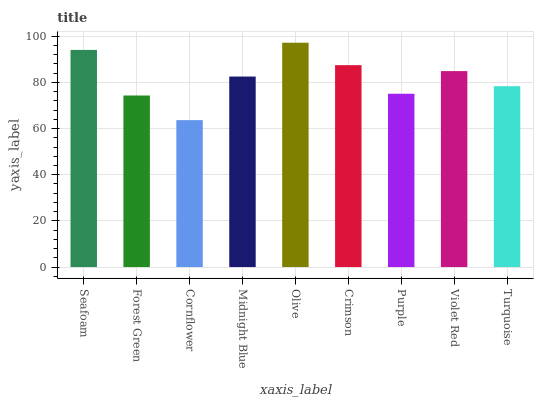Is Cornflower the minimum?
Answer yes or no. Yes. Is Olive the maximum?
Answer yes or no. Yes. Is Forest Green the minimum?
Answer yes or no. No. Is Forest Green the maximum?
Answer yes or no. No. Is Seafoam greater than Forest Green?
Answer yes or no. Yes. Is Forest Green less than Seafoam?
Answer yes or no. Yes. Is Forest Green greater than Seafoam?
Answer yes or no. No. Is Seafoam less than Forest Green?
Answer yes or no. No. Is Midnight Blue the high median?
Answer yes or no. Yes. Is Midnight Blue the low median?
Answer yes or no. Yes. Is Purple the high median?
Answer yes or no. No. Is Olive the low median?
Answer yes or no. No. 